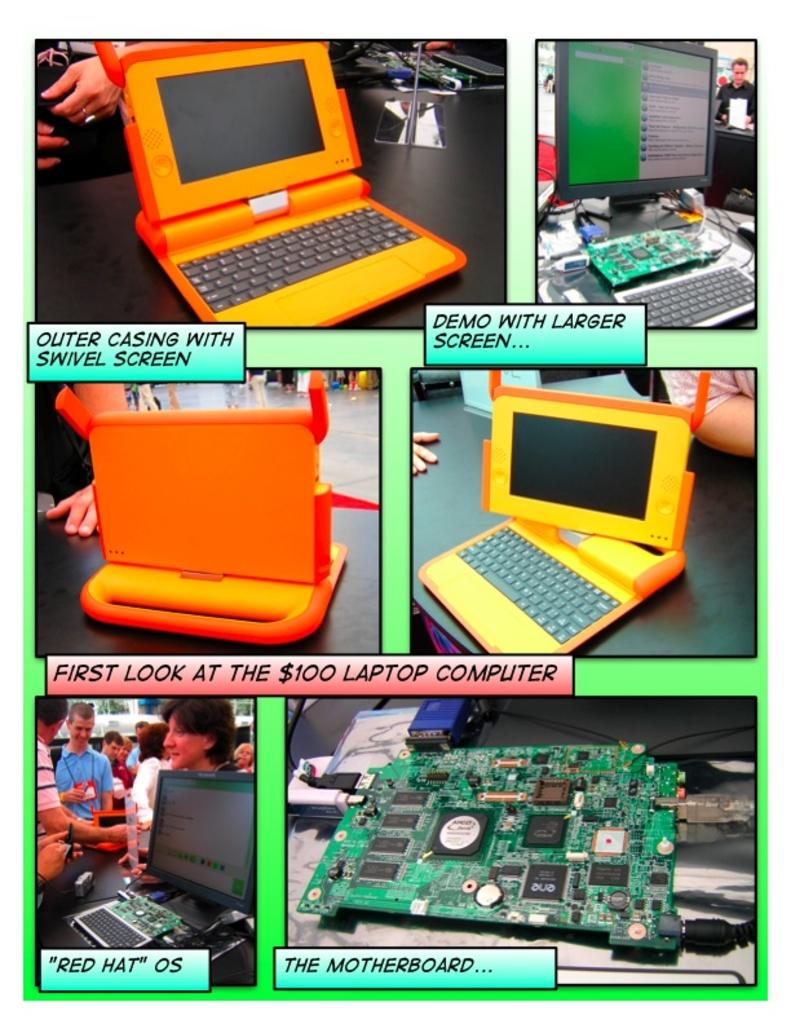<image>
Present a compact description of the photo's key features. an explanation of computers with pictures with one of the labels being 'the motherboard...' 